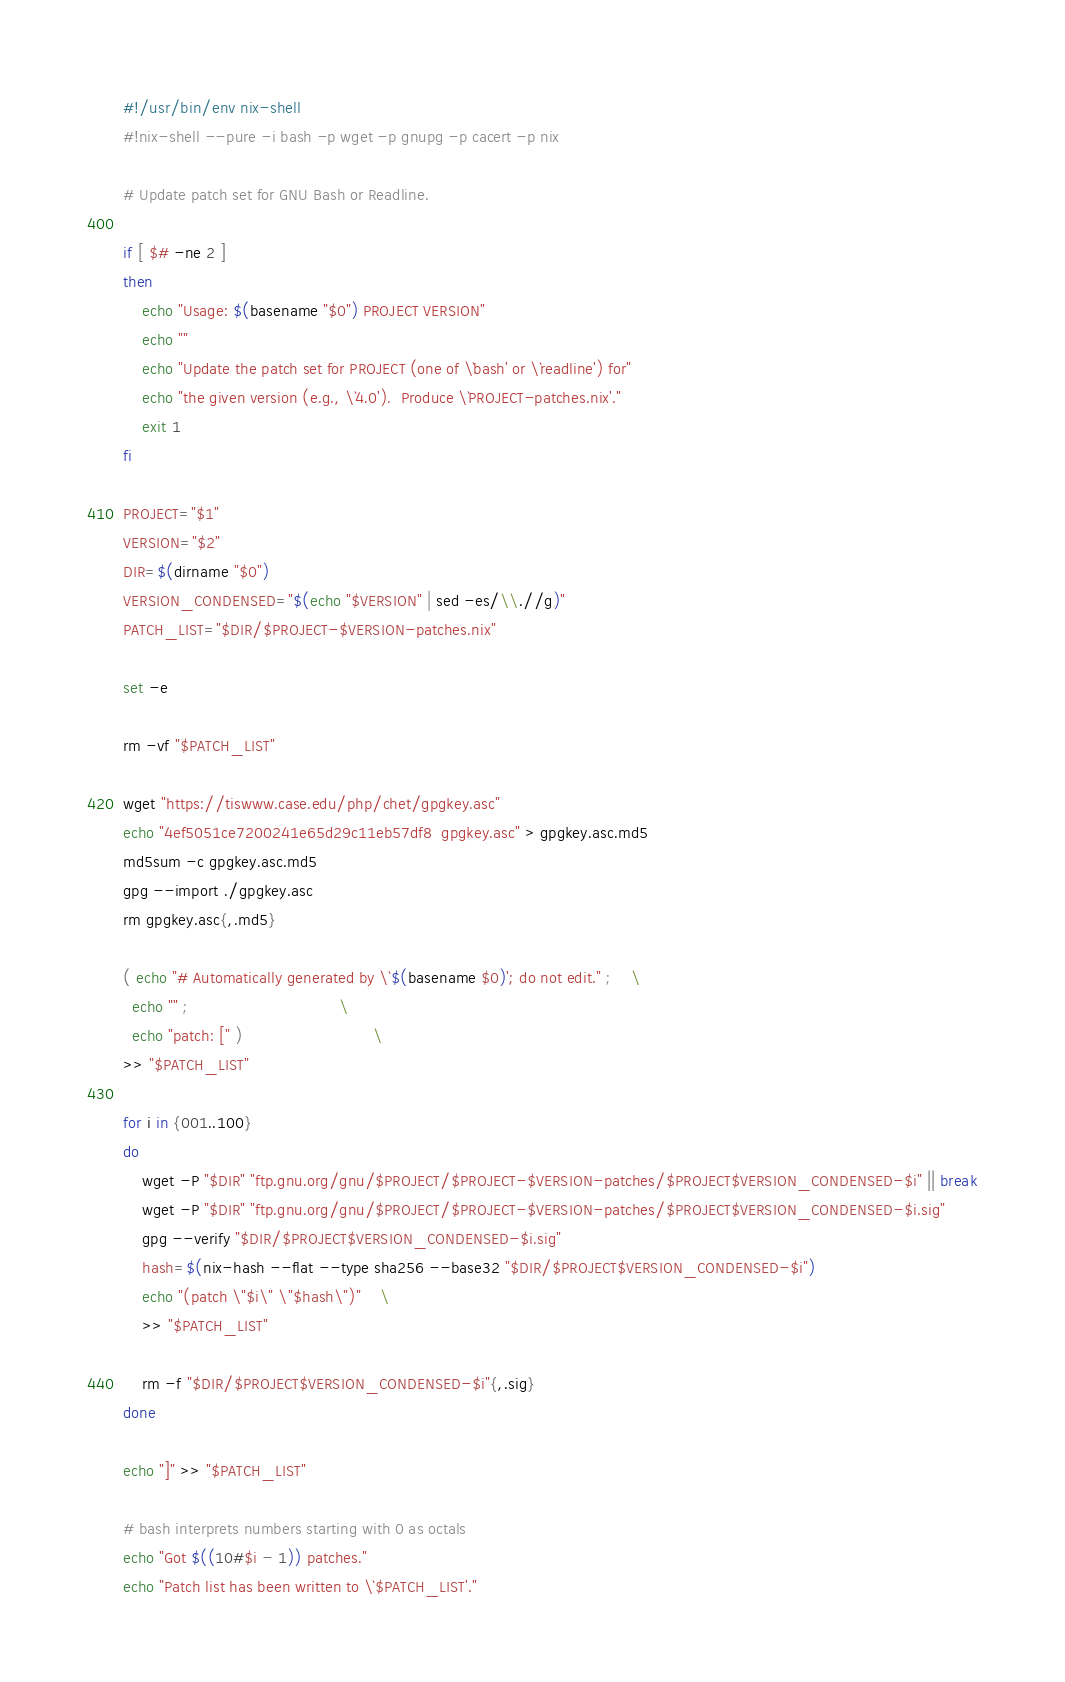<code> <loc_0><loc_0><loc_500><loc_500><_Bash_>#!/usr/bin/env nix-shell
#!nix-shell --pure -i bash -p wget -p gnupg -p cacert -p nix

# Update patch set for GNU Bash or Readline.

if [ $# -ne 2 ]
then
    echo "Usage: $(basename "$0") PROJECT VERSION"
    echo ""
    echo "Update the patch set for PROJECT (one of \`bash' or \`readline') for"
    echo "the given version (e.g., \`4.0').  Produce \`PROJECT-patches.nix'."
    exit 1
fi

PROJECT="$1"
VERSION="$2"
DIR=$(dirname "$0")
VERSION_CONDENSED="$(echo "$VERSION" | sed -es/\\.//g)"
PATCH_LIST="$DIR/$PROJECT-$VERSION-patches.nix"

set -e

rm -vf "$PATCH_LIST"

wget "https://tiswww.case.edu/php/chet/gpgkey.asc"
echo "4ef5051ce7200241e65d29c11eb57df8  gpgkey.asc" > gpgkey.asc.md5
md5sum -c gpgkey.asc.md5
gpg --import ./gpgkey.asc
rm gpgkey.asc{,.md5}

( echo "# Automatically generated by \`$(basename $0)'; do not edit." ;	\
  echo "" ;								\
  echo "patch: [" )							\
>> "$PATCH_LIST"

for i in {001..100}
do
    wget -P "$DIR" "ftp.gnu.org/gnu/$PROJECT/$PROJECT-$VERSION-patches/$PROJECT$VERSION_CONDENSED-$i" || break
    wget -P "$DIR" "ftp.gnu.org/gnu/$PROJECT/$PROJECT-$VERSION-patches/$PROJECT$VERSION_CONDENSED-$i.sig"
    gpg --verify "$DIR/$PROJECT$VERSION_CONDENSED-$i.sig"
    hash=$(nix-hash --flat --type sha256 --base32 "$DIR/$PROJECT$VERSION_CONDENSED-$i")
    echo "(patch \"$i\" \"$hash\")"	\
    >> "$PATCH_LIST"

    rm -f "$DIR/$PROJECT$VERSION_CONDENSED-$i"{,.sig}
done

echo "]" >> "$PATCH_LIST"

# bash interprets numbers starting with 0 as octals
echo "Got $((10#$i - 1)) patches."
echo "Patch list has been written to \`$PATCH_LIST'."
</code> 